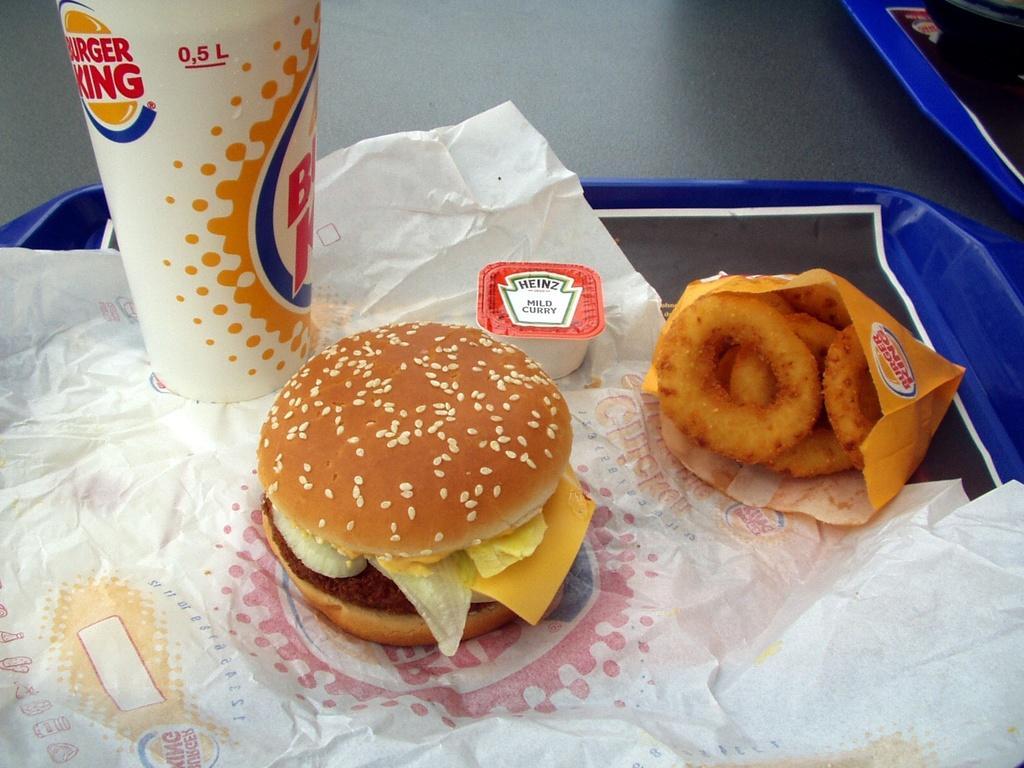Can you describe this image briefly? In this picture we can see the table and tray. On the train we can see the tissue papers, burger, glass, cup, paper cover and donate, In the top right corner we can see the bag on the table. 